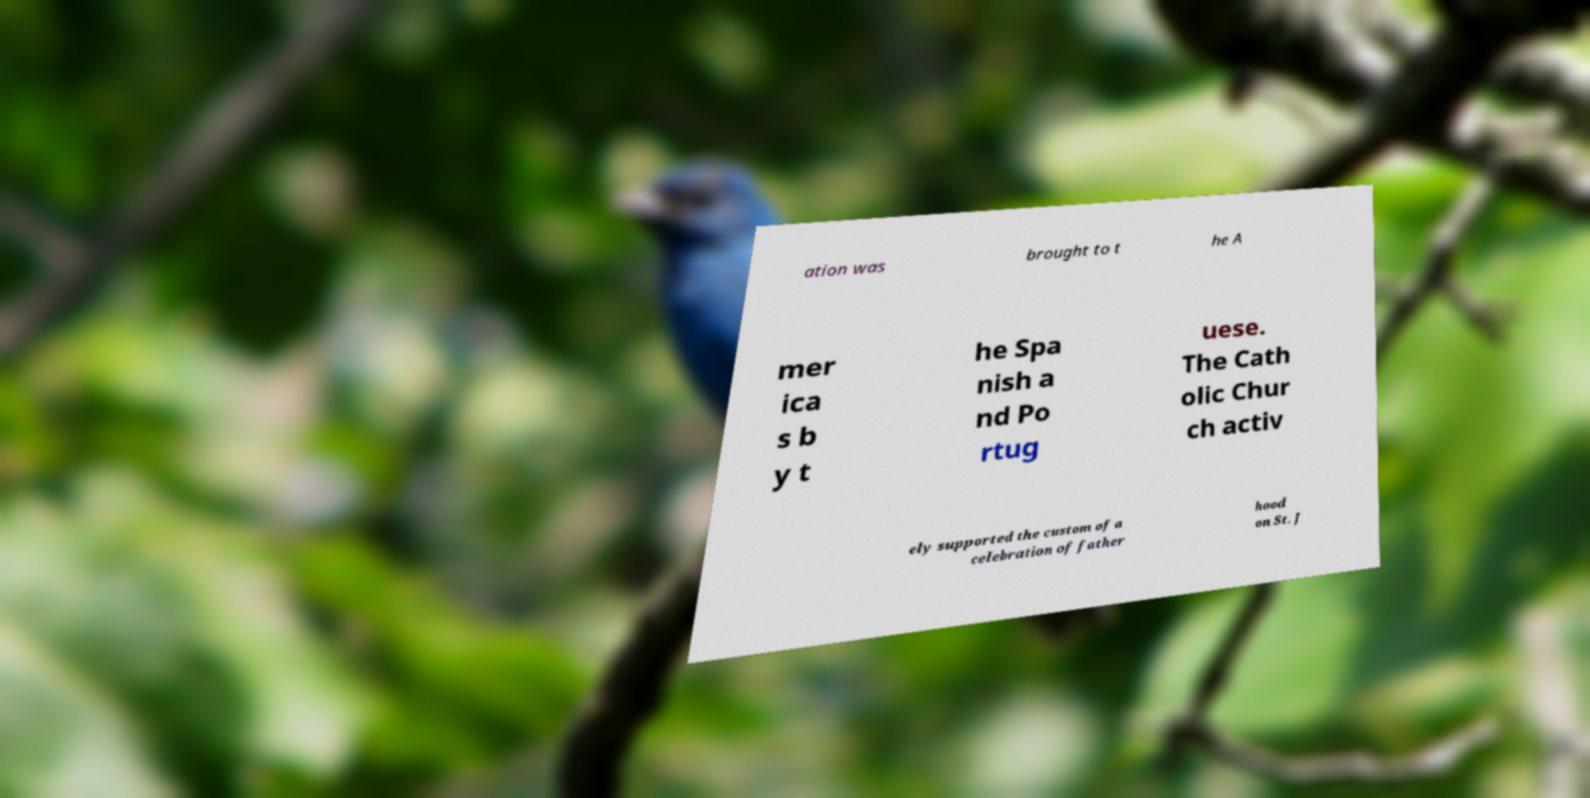Please identify and transcribe the text found in this image. ation was brought to t he A mer ica s b y t he Spa nish a nd Po rtug uese. The Cath olic Chur ch activ ely supported the custom of a celebration of father hood on St. J 